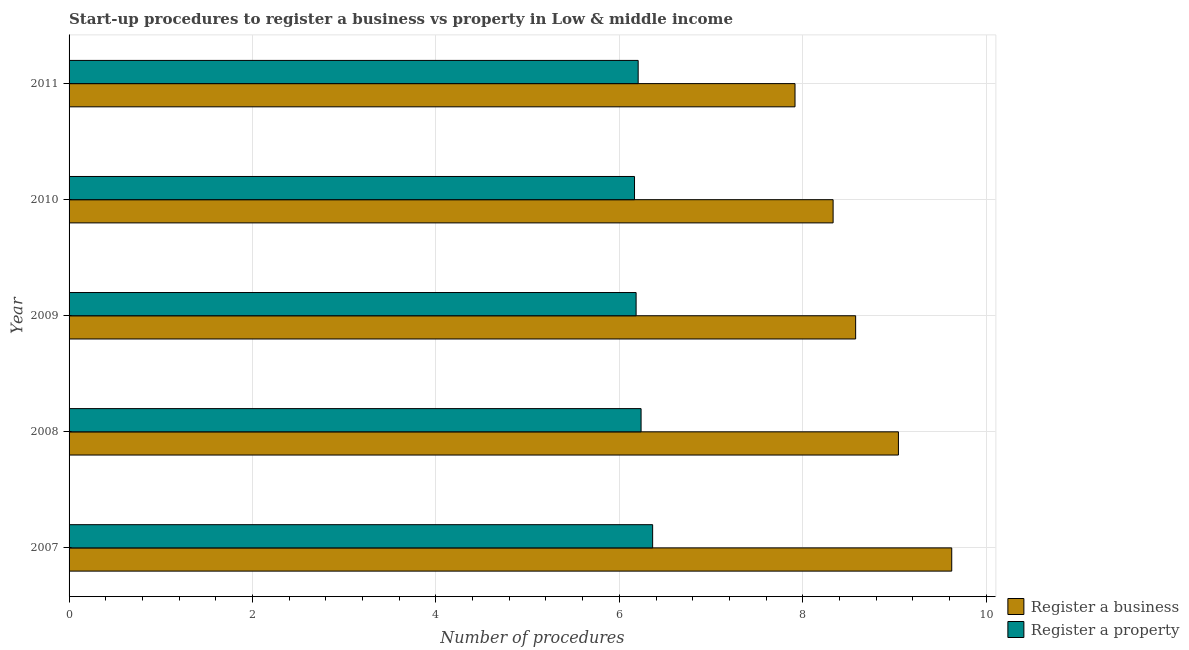How many different coloured bars are there?
Ensure brevity in your answer.  2. How many groups of bars are there?
Keep it short and to the point. 5. Are the number of bars per tick equal to the number of legend labels?
Make the answer very short. Yes. How many bars are there on the 3rd tick from the top?
Your answer should be very brief. 2. What is the label of the 1st group of bars from the top?
Keep it short and to the point. 2011. In how many cases, is the number of bars for a given year not equal to the number of legend labels?
Provide a succinct answer. 0. What is the number of procedures to register a business in 2008?
Your answer should be very brief. 9.04. Across all years, what is the maximum number of procedures to register a property?
Your answer should be very brief. 6.36. Across all years, what is the minimum number of procedures to register a business?
Your answer should be compact. 7.92. In which year was the number of procedures to register a property minimum?
Offer a very short reply. 2010. What is the total number of procedures to register a property in the graph?
Offer a very short reply. 31.15. What is the difference between the number of procedures to register a business in 2008 and that in 2010?
Ensure brevity in your answer.  0.71. What is the difference between the number of procedures to register a business in 2008 and the number of procedures to register a property in 2010?
Provide a succinct answer. 2.88. What is the average number of procedures to register a business per year?
Provide a short and direct response. 8.7. In the year 2009, what is the difference between the number of procedures to register a property and number of procedures to register a business?
Your response must be concise. -2.39. In how many years, is the number of procedures to register a business greater than 2.4 ?
Provide a succinct answer. 5. Is the difference between the number of procedures to register a business in 2010 and 2011 greater than the difference between the number of procedures to register a property in 2010 and 2011?
Provide a short and direct response. Yes. What is the difference between the highest and the second highest number of procedures to register a business?
Make the answer very short. 0.58. Is the sum of the number of procedures to register a business in 2007 and 2010 greater than the maximum number of procedures to register a property across all years?
Your answer should be compact. Yes. What does the 2nd bar from the top in 2010 represents?
Your answer should be compact. Register a business. What does the 2nd bar from the bottom in 2010 represents?
Your answer should be compact. Register a property. How many bars are there?
Your answer should be very brief. 10. Are all the bars in the graph horizontal?
Your response must be concise. Yes. How many years are there in the graph?
Provide a succinct answer. 5. Does the graph contain grids?
Your response must be concise. Yes. How many legend labels are there?
Provide a short and direct response. 2. How are the legend labels stacked?
Your response must be concise. Vertical. What is the title of the graph?
Offer a terse response. Start-up procedures to register a business vs property in Low & middle income. What is the label or title of the X-axis?
Your answer should be very brief. Number of procedures. What is the Number of procedures of Register a business in 2007?
Your answer should be compact. 9.62. What is the Number of procedures of Register a property in 2007?
Provide a short and direct response. 6.36. What is the Number of procedures of Register a business in 2008?
Make the answer very short. 9.04. What is the Number of procedures in Register a property in 2008?
Your response must be concise. 6.24. What is the Number of procedures in Register a business in 2009?
Your answer should be very brief. 8.58. What is the Number of procedures of Register a property in 2009?
Offer a very short reply. 6.18. What is the Number of procedures of Register a business in 2010?
Provide a short and direct response. 8.33. What is the Number of procedures in Register a property in 2010?
Provide a short and direct response. 6.17. What is the Number of procedures of Register a business in 2011?
Ensure brevity in your answer.  7.92. What is the Number of procedures in Register a property in 2011?
Ensure brevity in your answer.  6.21. Across all years, what is the maximum Number of procedures of Register a business?
Your answer should be very brief. 9.62. Across all years, what is the maximum Number of procedures in Register a property?
Offer a terse response. 6.36. Across all years, what is the minimum Number of procedures of Register a business?
Keep it short and to the point. 7.92. Across all years, what is the minimum Number of procedures of Register a property?
Give a very brief answer. 6.17. What is the total Number of procedures in Register a business in the graph?
Offer a very short reply. 43.49. What is the total Number of procedures in Register a property in the graph?
Provide a succinct answer. 31.15. What is the difference between the Number of procedures of Register a business in 2007 and that in 2008?
Offer a very short reply. 0.58. What is the difference between the Number of procedures of Register a property in 2007 and that in 2008?
Give a very brief answer. 0.13. What is the difference between the Number of procedures of Register a business in 2007 and that in 2009?
Offer a terse response. 1.05. What is the difference between the Number of procedures in Register a property in 2007 and that in 2009?
Your answer should be very brief. 0.18. What is the difference between the Number of procedures in Register a business in 2007 and that in 2010?
Keep it short and to the point. 1.29. What is the difference between the Number of procedures of Register a property in 2007 and that in 2010?
Make the answer very short. 0.2. What is the difference between the Number of procedures in Register a business in 2007 and that in 2011?
Make the answer very short. 1.71. What is the difference between the Number of procedures of Register a property in 2007 and that in 2011?
Give a very brief answer. 0.16. What is the difference between the Number of procedures of Register a business in 2008 and that in 2009?
Ensure brevity in your answer.  0.47. What is the difference between the Number of procedures of Register a property in 2008 and that in 2009?
Make the answer very short. 0.05. What is the difference between the Number of procedures of Register a business in 2008 and that in 2010?
Your answer should be compact. 0.71. What is the difference between the Number of procedures in Register a property in 2008 and that in 2010?
Make the answer very short. 0.07. What is the difference between the Number of procedures in Register a business in 2008 and that in 2011?
Give a very brief answer. 1.13. What is the difference between the Number of procedures of Register a property in 2008 and that in 2011?
Ensure brevity in your answer.  0.03. What is the difference between the Number of procedures of Register a business in 2009 and that in 2010?
Your answer should be very brief. 0.25. What is the difference between the Number of procedures in Register a property in 2009 and that in 2010?
Provide a short and direct response. 0.02. What is the difference between the Number of procedures of Register a business in 2009 and that in 2011?
Keep it short and to the point. 0.66. What is the difference between the Number of procedures of Register a property in 2009 and that in 2011?
Offer a terse response. -0.02. What is the difference between the Number of procedures in Register a business in 2010 and that in 2011?
Your answer should be compact. 0.42. What is the difference between the Number of procedures in Register a property in 2010 and that in 2011?
Keep it short and to the point. -0.04. What is the difference between the Number of procedures in Register a business in 2007 and the Number of procedures in Register a property in 2008?
Give a very brief answer. 3.39. What is the difference between the Number of procedures of Register a business in 2007 and the Number of procedures of Register a property in 2009?
Keep it short and to the point. 3.44. What is the difference between the Number of procedures in Register a business in 2007 and the Number of procedures in Register a property in 2010?
Give a very brief answer. 3.46. What is the difference between the Number of procedures of Register a business in 2007 and the Number of procedures of Register a property in 2011?
Offer a terse response. 3.42. What is the difference between the Number of procedures of Register a business in 2008 and the Number of procedures of Register a property in 2009?
Make the answer very short. 2.86. What is the difference between the Number of procedures of Register a business in 2008 and the Number of procedures of Register a property in 2010?
Provide a succinct answer. 2.88. What is the difference between the Number of procedures of Register a business in 2008 and the Number of procedures of Register a property in 2011?
Provide a short and direct response. 2.84. What is the difference between the Number of procedures of Register a business in 2009 and the Number of procedures of Register a property in 2010?
Offer a terse response. 2.41. What is the difference between the Number of procedures in Register a business in 2009 and the Number of procedures in Register a property in 2011?
Provide a succinct answer. 2.37. What is the difference between the Number of procedures in Register a business in 2010 and the Number of procedures in Register a property in 2011?
Provide a short and direct response. 2.13. What is the average Number of procedures in Register a business per year?
Your answer should be compact. 8.7. What is the average Number of procedures in Register a property per year?
Your answer should be compact. 6.23. In the year 2007, what is the difference between the Number of procedures in Register a business and Number of procedures in Register a property?
Give a very brief answer. 3.26. In the year 2008, what is the difference between the Number of procedures in Register a business and Number of procedures in Register a property?
Give a very brief answer. 2.81. In the year 2009, what is the difference between the Number of procedures in Register a business and Number of procedures in Register a property?
Keep it short and to the point. 2.39. In the year 2010, what is the difference between the Number of procedures in Register a business and Number of procedures in Register a property?
Give a very brief answer. 2.17. In the year 2011, what is the difference between the Number of procedures in Register a business and Number of procedures in Register a property?
Give a very brief answer. 1.71. What is the ratio of the Number of procedures of Register a business in 2007 to that in 2008?
Your response must be concise. 1.06. What is the ratio of the Number of procedures of Register a property in 2007 to that in 2008?
Provide a succinct answer. 1.02. What is the ratio of the Number of procedures in Register a business in 2007 to that in 2009?
Your answer should be very brief. 1.12. What is the ratio of the Number of procedures of Register a property in 2007 to that in 2009?
Ensure brevity in your answer.  1.03. What is the ratio of the Number of procedures of Register a business in 2007 to that in 2010?
Ensure brevity in your answer.  1.16. What is the ratio of the Number of procedures in Register a property in 2007 to that in 2010?
Your answer should be very brief. 1.03. What is the ratio of the Number of procedures of Register a business in 2007 to that in 2011?
Your answer should be very brief. 1.22. What is the ratio of the Number of procedures in Register a property in 2007 to that in 2011?
Your response must be concise. 1.03. What is the ratio of the Number of procedures in Register a business in 2008 to that in 2009?
Your response must be concise. 1.05. What is the ratio of the Number of procedures of Register a property in 2008 to that in 2009?
Give a very brief answer. 1.01. What is the ratio of the Number of procedures of Register a business in 2008 to that in 2010?
Keep it short and to the point. 1.09. What is the ratio of the Number of procedures in Register a property in 2008 to that in 2010?
Give a very brief answer. 1.01. What is the ratio of the Number of procedures in Register a business in 2008 to that in 2011?
Give a very brief answer. 1.14. What is the ratio of the Number of procedures of Register a property in 2008 to that in 2011?
Give a very brief answer. 1.01. What is the ratio of the Number of procedures of Register a business in 2009 to that in 2010?
Your response must be concise. 1.03. What is the ratio of the Number of procedures in Register a business in 2009 to that in 2011?
Your answer should be very brief. 1.08. What is the ratio of the Number of procedures in Register a business in 2010 to that in 2011?
Keep it short and to the point. 1.05. What is the difference between the highest and the second highest Number of procedures in Register a business?
Provide a succinct answer. 0.58. What is the difference between the highest and the second highest Number of procedures in Register a property?
Offer a terse response. 0.13. What is the difference between the highest and the lowest Number of procedures in Register a business?
Offer a very short reply. 1.71. What is the difference between the highest and the lowest Number of procedures of Register a property?
Provide a succinct answer. 0.2. 